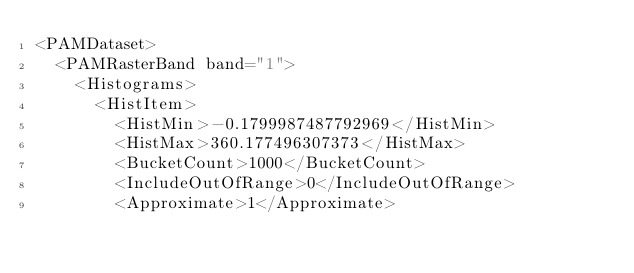Convert code to text. <code><loc_0><loc_0><loc_500><loc_500><_XML_><PAMDataset>
  <PAMRasterBand band="1">
    <Histograms>
      <HistItem>
        <HistMin>-0.1799987487792969</HistMin>
        <HistMax>360.177496307373</HistMax>
        <BucketCount>1000</BucketCount>
        <IncludeOutOfRange>0</IncludeOutOfRange>
        <Approximate>1</Approximate></code> 